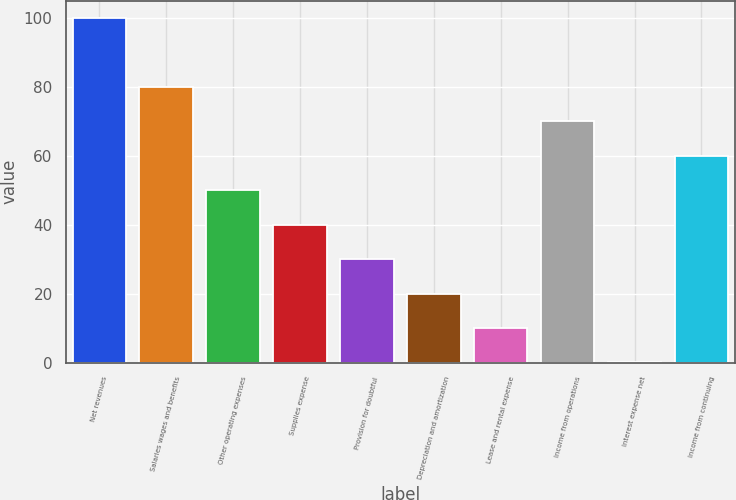Convert chart to OTSL. <chart><loc_0><loc_0><loc_500><loc_500><bar_chart><fcel>Net revenues<fcel>Salaries wages and benefits<fcel>Other operating expenses<fcel>Supplies expense<fcel>Provision for doubtful<fcel>Depreciation and amortization<fcel>Lease and rental expense<fcel>Income from operations<fcel>Interest expense net<fcel>Income from continuing<nl><fcel>100<fcel>80.02<fcel>50.05<fcel>40.06<fcel>30.07<fcel>20.08<fcel>10.09<fcel>70.03<fcel>0.1<fcel>60.04<nl></chart> 